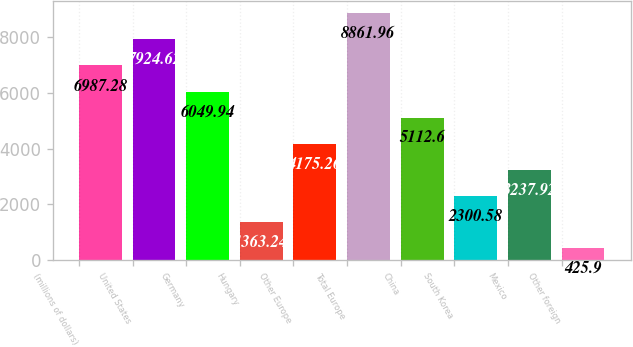Convert chart to OTSL. <chart><loc_0><loc_0><loc_500><loc_500><bar_chart><fcel>(millions of dollars)<fcel>United States<fcel>Germany<fcel>Hungary<fcel>Other Europe<fcel>Total Europe<fcel>China<fcel>South Korea<fcel>Mexico<fcel>Other foreign<nl><fcel>6987.28<fcel>7924.62<fcel>6049.94<fcel>1363.24<fcel>4175.26<fcel>8861.96<fcel>5112.6<fcel>2300.58<fcel>3237.92<fcel>425.9<nl></chart> 